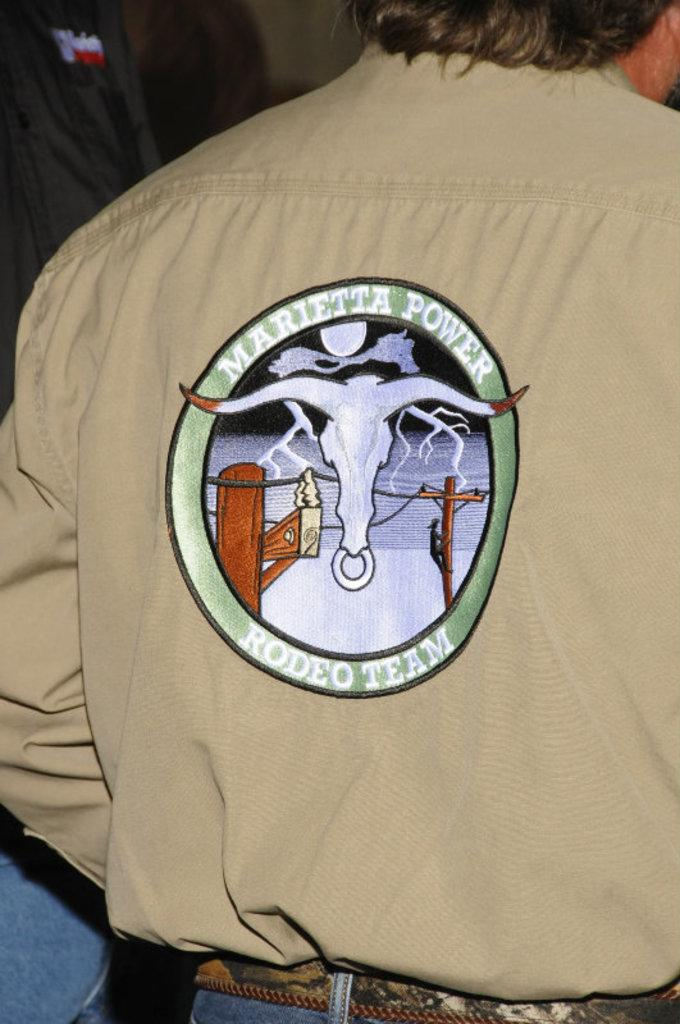<image>
Offer a succinct explanation of the picture presented. The back of a guys coat that says Marietta power rodeo team with a longhorn bull on it 